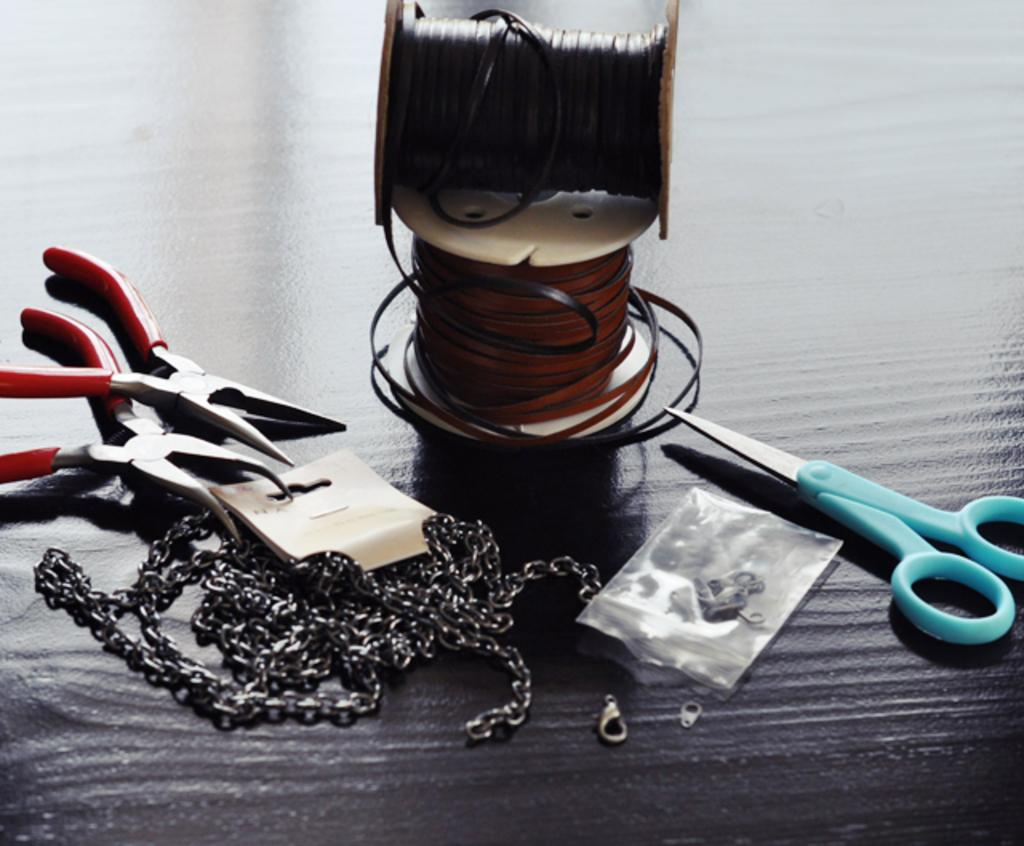What are the two main objects in the image? There are two threads in the image. What tools are present in the image that can be used for cutting? There are scissors and cutting pliers in the image. What type of material is depicted in the image? There are chains in the image. What else can be seen on a surface in the image? There are other objects on a surface in the image. What time does the quartz clock on the wall show in the image? There is no quartz clock or wall present in the image. What advice might the grandmother give to the person in the image? There is no grandmother or person present in the image, so it is impossible to determine any advice that might be given. 